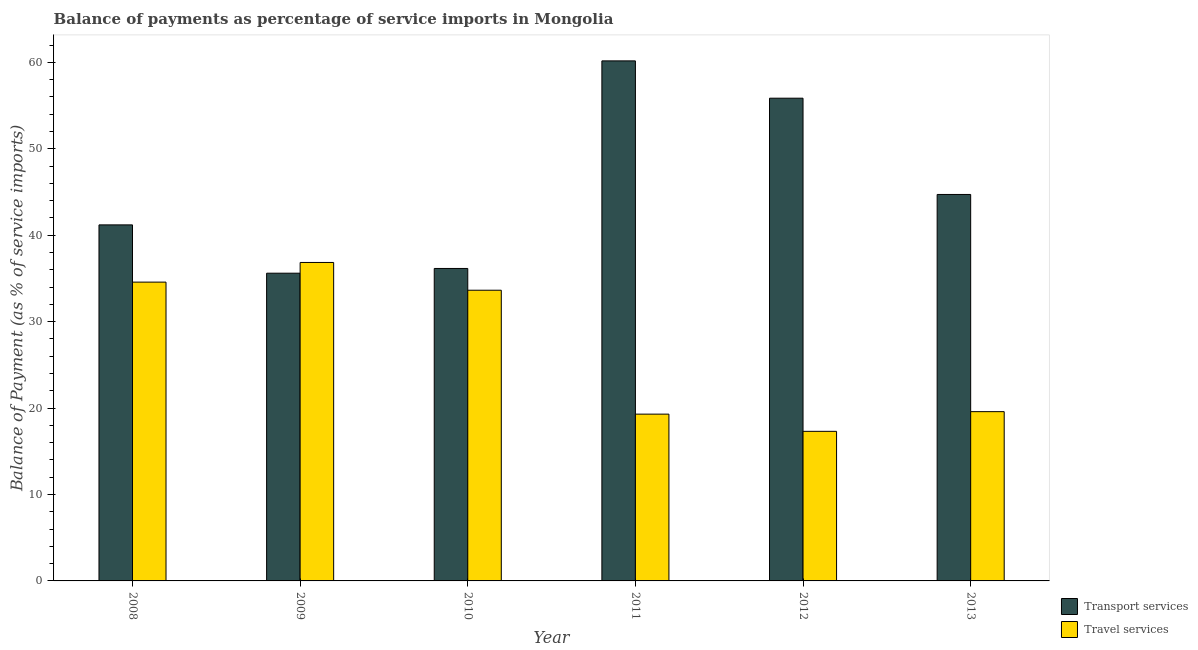How many groups of bars are there?
Keep it short and to the point. 6. What is the balance of payments of travel services in 2011?
Provide a short and direct response. 19.3. Across all years, what is the maximum balance of payments of transport services?
Your answer should be compact. 60.17. Across all years, what is the minimum balance of payments of travel services?
Keep it short and to the point. 17.31. In which year was the balance of payments of travel services maximum?
Offer a terse response. 2009. In which year was the balance of payments of transport services minimum?
Offer a terse response. 2009. What is the total balance of payments of transport services in the graph?
Provide a succinct answer. 273.69. What is the difference between the balance of payments of transport services in 2008 and that in 2011?
Ensure brevity in your answer.  -18.98. What is the difference between the balance of payments of transport services in 2012 and the balance of payments of travel services in 2010?
Offer a terse response. 19.7. What is the average balance of payments of transport services per year?
Ensure brevity in your answer.  45.62. In the year 2010, what is the difference between the balance of payments of transport services and balance of payments of travel services?
Your response must be concise. 0. What is the ratio of the balance of payments of travel services in 2008 to that in 2013?
Provide a succinct answer. 1.77. Is the difference between the balance of payments of travel services in 2012 and 2013 greater than the difference between the balance of payments of transport services in 2012 and 2013?
Your answer should be compact. No. What is the difference between the highest and the second highest balance of payments of transport services?
Provide a short and direct response. 4.32. What is the difference between the highest and the lowest balance of payments of travel services?
Your answer should be compact. 19.54. Is the sum of the balance of payments of travel services in 2008 and 2011 greater than the maximum balance of payments of transport services across all years?
Provide a succinct answer. Yes. What does the 1st bar from the left in 2011 represents?
Offer a very short reply. Transport services. What does the 1st bar from the right in 2013 represents?
Offer a very short reply. Travel services. Are all the bars in the graph horizontal?
Keep it short and to the point. No. What is the difference between two consecutive major ticks on the Y-axis?
Provide a short and direct response. 10. Does the graph contain any zero values?
Your answer should be very brief. No. Does the graph contain grids?
Make the answer very short. No. What is the title of the graph?
Your response must be concise. Balance of payments as percentage of service imports in Mongolia. Does "Research and Development" appear as one of the legend labels in the graph?
Provide a succinct answer. No. What is the label or title of the X-axis?
Offer a very short reply. Year. What is the label or title of the Y-axis?
Offer a terse response. Balance of Payment (as % of service imports). What is the Balance of Payment (as % of service imports) in Transport services in 2008?
Give a very brief answer. 41.19. What is the Balance of Payment (as % of service imports) in Travel services in 2008?
Your answer should be very brief. 34.57. What is the Balance of Payment (as % of service imports) of Transport services in 2009?
Make the answer very short. 35.6. What is the Balance of Payment (as % of service imports) of Travel services in 2009?
Your response must be concise. 36.85. What is the Balance of Payment (as % of service imports) of Transport services in 2010?
Your answer should be very brief. 36.15. What is the Balance of Payment (as % of service imports) in Travel services in 2010?
Your answer should be compact. 33.63. What is the Balance of Payment (as % of service imports) in Transport services in 2011?
Offer a terse response. 60.17. What is the Balance of Payment (as % of service imports) of Travel services in 2011?
Your answer should be very brief. 19.3. What is the Balance of Payment (as % of service imports) of Transport services in 2012?
Your answer should be very brief. 55.85. What is the Balance of Payment (as % of service imports) of Travel services in 2012?
Give a very brief answer. 17.31. What is the Balance of Payment (as % of service imports) of Transport services in 2013?
Your response must be concise. 44.71. What is the Balance of Payment (as % of service imports) of Travel services in 2013?
Give a very brief answer. 19.59. Across all years, what is the maximum Balance of Payment (as % of service imports) in Transport services?
Give a very brief answer. 60.17. Across all years, what is the maximum Balance of Payment (as % of service imports) of Travel services?
Ensure brevity in your answer.  36.85. Across all years, what is the minimum Balance of Payment (as % of service imports) of Transport services?
Offer a very short reply. 35.6. Across all years, what is the minimum Balance of Payment (as % of service imports) of Travel services?
Your answer should be compact. 17.31. What is the total Balance of Payment (as % of service imports) in Transport services in the graph?
Offer a terse response. 273.69. What is the total Balance of Payment (as % of service imports) of Travel services in the graph?
Offer a very short reply. 161.25. What is the difference between the Balance of Payment (as % of service imports) in Transport services in 2008 and that in 2009?
Give a very brief answer. 5.59. What is the difference between the Balance of Payment (as % of service imports) in Travel services in 2008 and that in 2009?
Provide a short and direct response. -2.27. What is the difference between the Balance of Payment (as % of service imports) in Transport services in 2008 and that in 2010?
Make the answer very short. 5.04. What is the difference between the Balance of Payment (as % of service imports) in Travel services in 2008 and that in 2010?
Offer a terse response. 0.94. What is the difference between the Balance of Payment (as % of service imports) of Transport services in 2008 and that in 2011?
Provide a short and direct response. -18.98. What is the difference between the Balance of Payment (as % of service imports) in Travel services in 2008 and that in 2011?
Provide a succinct answer. 15.27. What is the difference between the Balance of Payment (as % of service imports) of Transport services in 2008 and that in 2012?
Your answer should be very brief. -14.66. What is the difference between the Balance of Payment (as % of service imports) of Travel services in 2008 and that in 2012?
Give a very brief answer. 17.26. What is the difference between the Balance of Payment (as % of service imports) in Transport services in 2008 and that in 2013?
Provide a short and direct response. -3.52. What is the difference between the Balance of Payment (as % of service imports) of Travel services in 2008 and that in 2013?
Make the answer very short. 14.99. What is the difference between the Balance of Payment (as % of service imports) in Transport services in 2009 and that in 2010?
Your response must be concise. -0.55. What is the difference between the Balance of Payment (as % of service imports) in Travel services in 2009 and that in 2010?
Provide a succinct answer. 3.21. What is the difference between the Balance of Payment (as % of service imports) of Transport services in 2009 and that in 2011?
Your response must be concise. -24.57. What is the difference between the Balance of Payment (as % of service imports) in Travel services in 2009 and that in 2011?
Offer a terse response. 17.55. What is the difference between the Balance of Payment (as % of service imports) of Transport services in 2009 and that in 2012?
Your answer should be very brief. -20.25. What is the difference between the Balance of Payment (as % of service imports) in Travel services in 2009 and that in 2012?
Make the answer very short. 19.54. What is the difference between the Balance of Payment (as % of service imports) in Transport services in 2009 and that in 2013?
Keep it short and to the point. -9.11. What is the difference between the Balance of Payment (as % of service imports) in Travel services in 2009 and that in 2013?
Your response must be concise. 17.26. What is the difference between the Balance of Payment (as % of service imports) in Transport services in 2010 and that in 2011?
Your answer should be compact. -24.02. What is the difference between the Balance of Payment (as % of service imports) in Travel services in 2010 and that in 2011?
Offer a terse response. 14.34. What is the difference between the Balance of Payment (as % of service imports) of Transport services in 2010 and that in 2012?
Offer a terse response. -19.7. What is the difference between the Balance of Payment (as % of service imports) of Travel services in 2010 and that in 2012?
Give a very brief answer. 16.33. What is the difference between the Balance of Payment (as % of service imports) of Transport services in 2010 and that in 2013?
Provide a succinct answer. -8.56. What is the difference between the Balance of Payment (as % of service imports) of Travel services in 2010 and that in 2013?
Ensure brevity in your answer.  14.05. What is the difference between the Balance of Payment (as % of service imports) of Transport services in 2011 and that in 2012?
Your response must be concise. 4.32. What is the difference between the Balance of Payment (as % of service imports) of Travel services in 2011 and that in 2012?
Your answer should be very brief. 1.99. What is the difference between the Balance of Payment (as % of service imports) in Transport services in 2011 and that in 2013?
Make the answer very short. 15.46. What is the difference between the Balance of Payment (as % of service imports) of Travel services in 2011 and that in 2013?
Ensure brevity in your answer.  -0.29. What is the difference between the Balance of Payment (as % of service imports) in Transport services in 2012 and that in 2013?
Make the answer very short. 11.14. What is the difference between the Balance of Payment (as % of service imports) in Travel services in 2012 and that in 2013?
Your answer should be very brief. -2.28. What is the difference between the Balance of Payment (as % of service imports) of Transport services in 2008 and the Balance of Payment (as % of service imports) of Travel services in 2009?
Keep it short and to the point. 4.35. What is the difference between the Balance of Payment (as % of service imports) in Transport services in 2008 and the Balance of Payment (as % of service imports) in Travel services in 2010?
Provide a short and direct response. 7.56. What is the difference between the Balance of Payment (as % of service imports) in Transport services in 2008 and the Balance of Payment (as % of service imports) in Travel services in 2011?
Keep it short and to the point. 21.9. What is the difference between the Balance of Payment (as % of service imports) in Transport services in 2008 and the Balance of Payment (as % of service imports) in Travel services in 2012?
Provide a short and direct response. 23.89. What is the difference between the Balance of Payment (as % of service imports) in Transport services in 2008 and the Balance of Payment (as % of service imports) in Travel services in 2013?
Your answer should be compact. 21.61. What is the difference between the Balance of Payment (as % of service imports) in Transport services in 2009 and the Balance of Payment (as % of service imports) in Travel services in 2010?
Your answer should be very brief. 1.97. What is the difference between the Balance of Payment (as % of service imports) of Transport services in 2009 and the Balance of Payment (as % of service imports) of Travel services in 2011?
Ensure brevity in your answer.  16.31. What is the difference between the Balance of Payment (as % of service imports) of Transport services in 2009 and the Balance of Payment (as % of service imports) of Travel services in 2012?
Your answer should be compact. 18.3. What is the difference between the Balance of Payment (as % of service imports) in Transport services in 2009 and the Balance of Payment (as % of service imports) in Travel services in 2013?
Ensure brevity in your answer.  16.02. What is the difference between the Balance of Payment (as % of service imports) of Transport services in 2010 and the Balance of Payment (as % of service imports) of Travel services in 2011?
Provide a short and direct response. 16.86. What is the difference between the Balance of Payment (as % of service imports) in Transport services in 2010 and the Balance of Payment (as % of service imports) in Travel services in 2012?
Provide a short and direct response. 18.85. What is the difference between the Balance of Payment (as % of service imports) of Transport services in 2010 and the Balance of Payment (as % of service imports) of Travel services in 2013?
Give a very brief answer. 16.57. What is the difference between the Balance of Payment (as % of service imports) in Transport services in 2011 and the Balance of Payment (as % of service imports) in Travel services in 2012?
Your response must be concise. 42.86. What is the difference between the Balance of Payment (as % of service imports) in Transport services in 2011 and the Balance of Payment (as % of service imports) in Travel services in 2013?
Make the answer very short. 40.59. What is the difference between the Balance of Payment (as % of service imports) in Transport services in 2012 and the Balance of Payment (as % of service imports) in Travel services in 2013?
Provide a succinct answer. 36.27. What is the average Balance of Payment (as % of service imports) in Transport services per year?
Provide a succinct answer. 45.62. What is the average Balance of Payment (as % of service imports) of Travel services per year?
Your answer should be compact. 26.87. In the year 2008, what is the difference between the Balance of Payment (as % of service imports) of Transport services and Balance of Payment (as % of service imports) of Travel services?
Your answer should be compact. 6.62. In the year 2009, what is the difference between the Balance of Payment (as % of service imports) in Transport services and Balance of Payment (as % of service imports) in Travel services?
Provide a short and direct response. -1.24. In the year 2010, what is the difference between the Balance of Payment (as % of service imports) of Transport services and Balance of Payment (as % of service imports) of Travel services?
Ensure brevity in your answer.  2.52. In the year 2011, what is the difference between the Balance of Payment (as % of service imports) in Transport services and Balance of Payment (as % of service imports) in Travel services?
Provide a short and direct response. 40.87. In the year 2012, what is the difference between the Balance of Payment (as % of service imports) in Transport services and Balance of Payment (as % of service imports) in Travel services?
Make the answer very short. 38.54. In the year 2013, what is the difference between the Balance of Payment (as % of service imports) of Transport services and Balance of Payment (as % of service imports) of Travel services?
Offer a very short reply. 25.13. What is the ratio of the Balance of Payment (as % of service imports) of Transport services in 2008 to that in 2009?
Offer a terse response. 1.16. What is the ratio of the Balance of Payment (as % of service imports) in Travel services in 2008 to that in 2009?
Your response must be concise. 0.94. What is the ratio of the Balance of Payment (as % of service imports) of Transport services in 2008 to that in 2010?
Ensure brevity in your answer.  1.14. What is the ratio of the Balance of Payment (as % of service imports) in Travel services in 2008 to that in 2010?
Provide a succinct answer. 1.03. What is the ratio of the Balance of Payment (as % of service imports) of Transport services in 2008 to that in 2011?
Offer a terse response. 0.68. What is the ratio of the Balance of Payment (as % of service imports) in Travel services in 2008 to that in 2011?
Provide a succinct answer. 1.79. What is the ratio of the Balance of Payment (as % of service imports) in Transport services in 2008 to that in 2012?
Offer a very short reply. 0.74. What is the ratio of the Balance of Payment (as % of service imports) of Travel services in 2008 to that in 2012?
Offer a terse response. 2. What is the ratio of the Balance of Payment (as % of service imports) of Transport services in 2008 to that in 2013?
Your answer should be very brief. 0.92. What is the ratio of the Balance of Payment (as % of service imports) in Travel services in 2008 to that in 2013?
Your answer should be compact. 1.77. What is the ratio of the Balance of Payment (as % of service imports) in Travel services in 2009 to that in 2010?
Offer a very short reply. 1.1. What is the ratio of the Balance of Payment (as % of service imports) of Transport services in 2009 to that in 2011?
Give a very brief answer. 0.59. What is the ratio of the Balance of Payment (as % of service imports) in Travel services in 2009 to that in 2011?
Provide a succinct answer. 1.91. What is the ratio of the Balance of Payment (as % of service imports) of Transport services in 2009 to that in 2012?
Offer a terse response. 0.64. What is the ratio of the Balance of Payment (as % of service imports) in Travel services in 2009 to that in 2012?
Offer a terse response. 2.13. What is the ratio of the Balance of Payment (as % of service imports) of Transport services in 2009 to that in 2013?
Ensure brevity in your answer.  0.8. What is the ratio of the Balance of Payment (as % of service imports) in Travel services in 2009 to that in 2013?
Your answer should be compact. 1.88. What is the ratio of the Balance of Payment (as % of service imports) of Transport services in 2010 to that in 2011?
Provide a succinct answer. 0.6. What is the ratio of the Balance of Payment (as % of service imports) of Travel services in 2010 to that in 2011?
Your answer should be very brief. 1.74. What is the ratio of the Balance of Payment (as % of service imports) of Transport services in 2010 to that in 2012?
Your response must be concise. 0.65. What is the ratio of the Balance of Payment (as % of service imports) of Travel services in 2010 to that in 2012?
Give a very brief answer. 1.94. What is the ratio of the Balance of Payment (as % of service imports) of Transport services in 2010 to that in 2013?
Your answer should be very brief. 0.81. What is the ratio of the Balance of Payment (as % of service imports) in Travel services in 2010 to that in 2013?
Your response must be concise. 1.72. What is the ratio of the Balance of Payment (as % of service imports) of Transport services in 2011 to that in 2012?
Keep it short and to the point. 1.08. What is the ratio of the Balance of Payment (as % of service imports) of Travel services in 2011 to that in 2012?
Give a very brief answer. 1.11. What is the ratio of the Balance of Payment (as % of service imports) of Transport services in 2011 to that in 2013?
Give a very brief answer. 1.35. What is the ratio of the Balance of Payment (as % of service imports) of Transport services in 2012 to that in 2013?
Your answer should be compact. 1.25. What is the ratio of the Balance of Payment (as % of service imports) of Travel services in 2012 to that in 2013?
Give a very brief answer. 0.88. What is the difference between the highest and the second highest Balance of Payment (as % of service imports) of Transport services?
Offer a very short reply. 4.32. What is the difference between the highest and the second highest Balance of Payment (as % of service imports) of Travel services?
Make the answer very short. 2.27. What is the difference between the highest and the lowest Balance of Payment (as % of service imports) in Transport services?
Provide a succinct answer. 24.57. What is the difference between the highest and the lowest Balance of Payment (as % of service imports) of Travel services?
Offer a terse response. 19.54. 